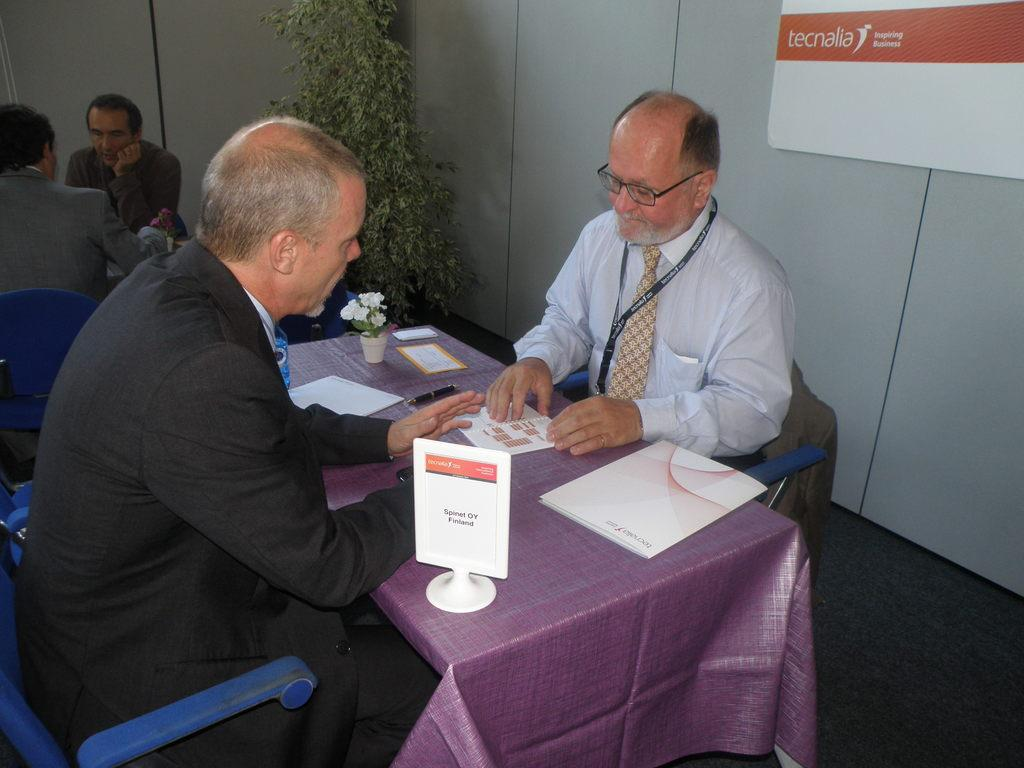How many people are seated in the image? There are two men seated on chairs in the image. What is on the table in the image? There are papers on the table in the image. Who else is seated at the table in the image? There are two people seated on the other side of the table in the image. What type of vegetation is visible in the image? There is a plant visible in the image. How many dimes can be seen on the ground in the image? There is no mention of dimes or a ground in the image; it only shows two men seated on chairs, papers on a table, two people on the other side of the table, and a plant. 